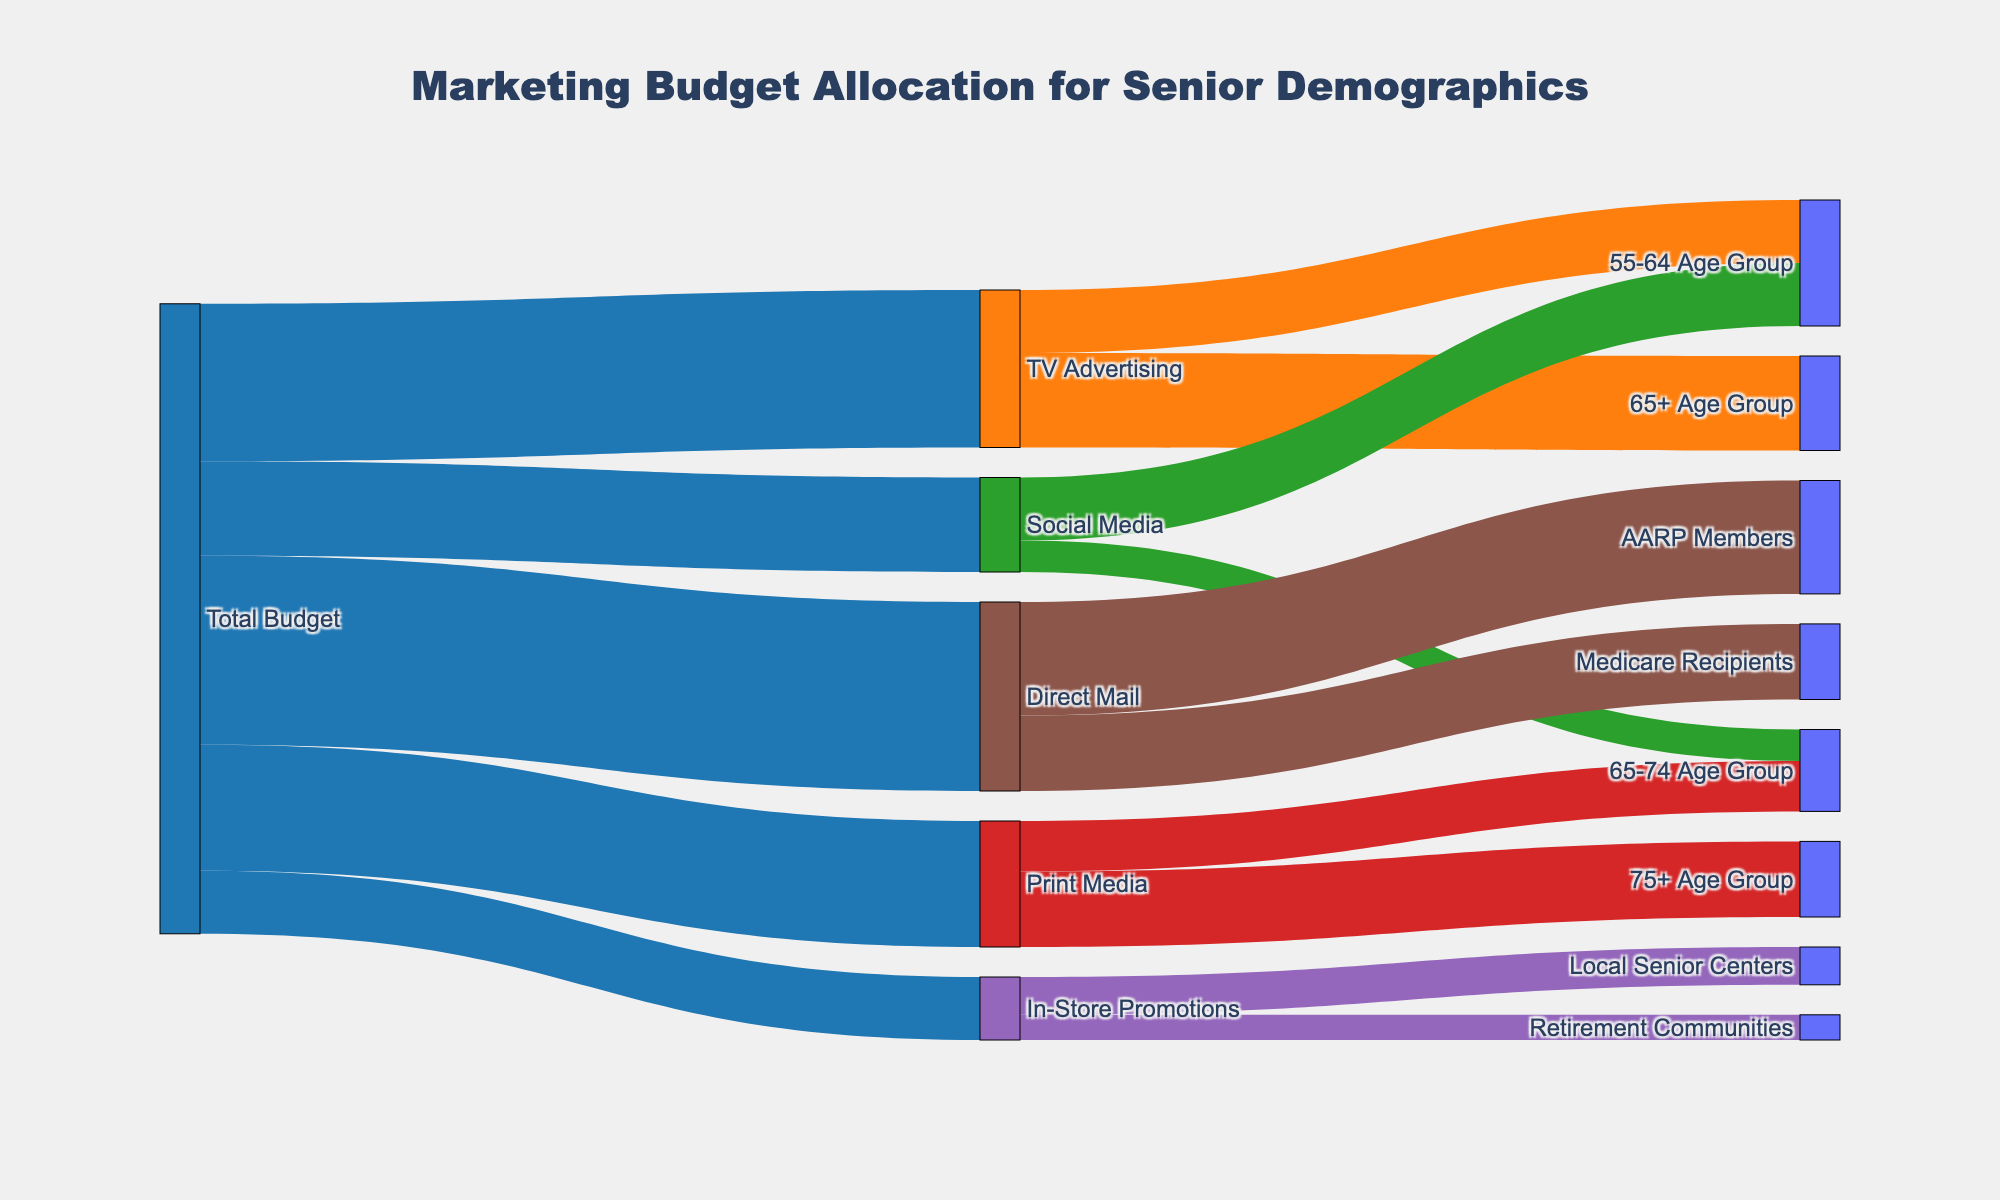What's the title of the figure? The title is positioned at the top central part of the Sankey diagram. It typically summarizes the overall theme of the chart. In this diagram, the title provided is "Marketing Budget Allocation for Senior Demographics".
Answer: Marketing Budget Allocation for Senior Demographics What are the main categories receiving portions of the total budget? The categories are indicated by nodes directly connected to the "Total Budget" node. These categories include "TV Advertising", "Social Media", "Print Media", "In-Store Promotions", and "Direct Mail".
Answer: TV Advertising, Social Media, Print Media, In-Store Promotions, Direct Mail How much of the budget is allocated to Direct Mail? The value linked from the "Total Budget" node to the "Direct Mail" node represents the allocation. According to the data, it is $30,000.
Answer: $30,000 Which senior demographic receives the largest portion of the budget through Direct Mail? Follow the links from "Direct Mail" to the respective senior demographics. The link with the highest value from "Direct Mail" is to "AARP Members", which is $18,000. This is the largest portion to a demographic within Direct Mail.
Answer: AARP Members How does the allocation for 55-64 Age Group compare between TV Advertising and Social Media? Evaluate the links connected with "55-64 Age Group" from "TV Advertising" and "Social Media". TV Advertising allocates $10,000 and Social Media also allocates $10,000. Both are equal.
Answer: Equal Sum up the total budget allocated to the 65-74 Age Group for social media and print media? Identify the allocations to the "65-74 Age Group" for both categories and add them. Social media allocates $5,000 and print media allocates $8,000. Therefore, the sum is $5,000 + $8,000 = $13,000.
Answer: $13,000 Which marketing category has the smallest budget allocation? Among the primary categories sourced from "Total Budget," the smallest value indicates the category with the lowest allocation. "In-Store Promotions" receives the smallest budget at $10,000.
Answer: In-Store Promotions What demographic group receives the largest overall marketing allocation? Sum up values across all marketing categories for each demographic group and identify the maximum. Adding for "AARP Members," $18,000 (Direct Mail only) is the highest single allocation.
Answer: AARP Members What is the combined budget for TV Advertising and Social Media? Add the allocations to TV Advertising ($25,000) and Social Media ($15,000). Thus, the combined budget is $25,000 + $15,000 = $40,000.
Answer: $40,000 To which groups does Print Media allocate its budget? Follow the arrows starting from "Print Media" to subsequent nodes, showing the recipient groups. These include "75+ Age Group" and "65-74 Age Group".
Answer: 75+ Age Group, 65-74 Age Group 